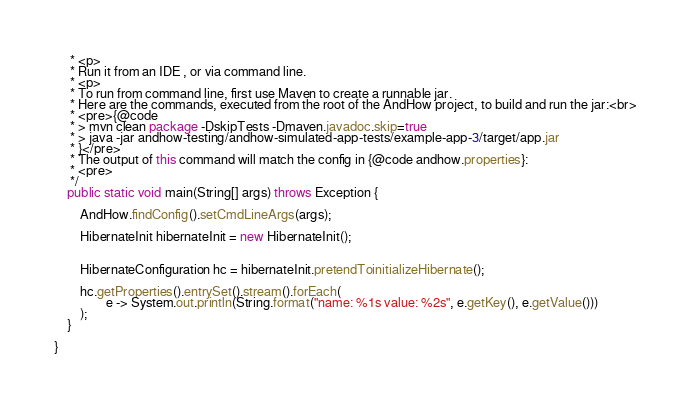Convert code to text. <code><loc_0><loc_0><loc_500><loc_500><_Java_>	 * <p>
	 * Run it from an IDE , or via command line.
	 * <p>
	 * To run from command line, first use Maven to create a runnable jar.
	 * Here are the commands, executed from the root of the AndHow project, to build and run the jar:<br>
	 * <pre>{@code
	 * > mvn clean package -DskipTests -Dmaven.javadoc.skip=true
	 * > java -jar andhow-testing/andhow-simulated-app-tests/example-app-3/target/app.jar
	 * }</pre>
	 * The output of this command will match the config in {@code andhow.properties}:
	 * <pre>
	 */
	public static void main(String[] args) throws Exception {

		AndHow.findConfig().setCmdLineArgs(args);

		HibernateInit hibernateInit = new HibernateInit();


		HibernateConfiguration hc = hibernateInit.pretendToinitializeHibernate();

		hc.getProperties().entrySet().stream().forEach(
				e -> System.out.println(String.format("name: %1s value: %2s", e.getKey(), e.getValue()))
		);
	}

}
</code> 